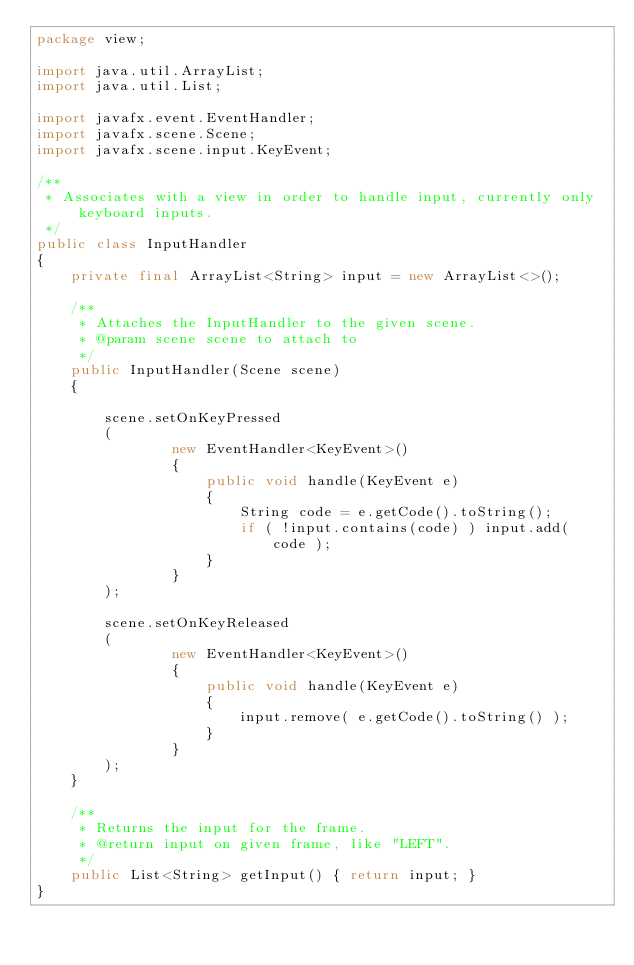Convert code to text. <code><loc_0><loc_0><loc_500><loc_500><_Java_>package view;

import java.util.ArrayList;
import java.util.List;

import javafx.event.EventHandler;
import javafx.scene.Scene;
import javafx.scene.input.KeyEvent;

/**
 * Associates with a view in order to handle input, currently only keyboard inputs.
 */
public class InputHandler
{
	private final ArrayList<String> input = new ArrayList<>();

	/**
	 * Attaches the InputHandler to the given scene.
	 * @param scene scene to attach to
	 */
	public InputHandler(Scene scene)
	{
		
        scene.setOnKeyPressed 
        (
                new EventHandler<KeyEvent>()
                {
                    public void handle(KeyEvent e)
                    {
                        String code = e.getCode().toString();
                        if ( !input.contains(code) ) input.add( code );
                    }
                }
        );
     
        scene.setOnKeyReleased
        (
                new EventHandler<KeyEvent>()
                {
                    public void handle(KeyEvent e)
                    {
                        input.remove( e.getCode().toString() );
                    }
                }
        );
	}

	/**
	 * Returns the input for the frame.
	 * @return input on given frame, like "LEFT".
	 */
	public List<String> getInput() { return input; }
}</code> 